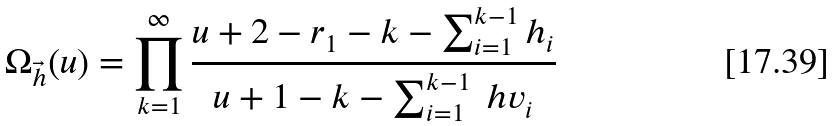<formula> <loc_0><loc_0><loc_500><loc_500>\Omega _ { \vec { h } } ( u ) = \prod _ { k = 1 } ^ { \infty } \frac { u + 2 - r _ { 1 } - k - \sum _ { i = 1 } ^ { k - 1 } h _ { i } } { u + 1 - k - \sum _ { i = 1 } ^ { k - 1 } \ h v _ { i } }</formula> 